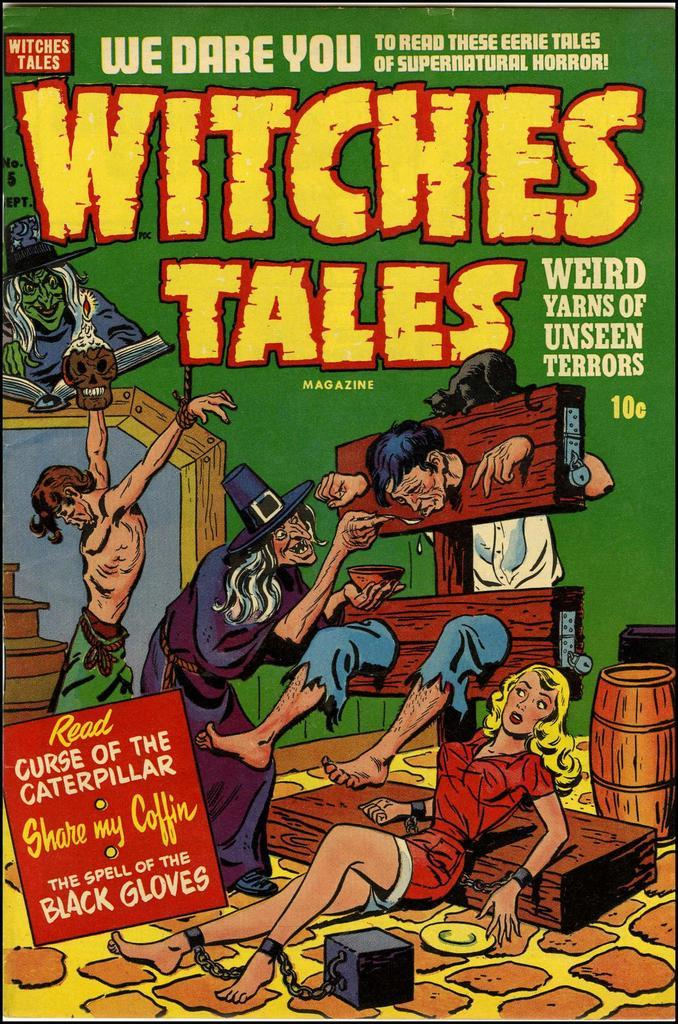<image>
Offer a succinct explanation of the picture presented. A comic book called Witches Tales shows a witch feeding prisoners. 